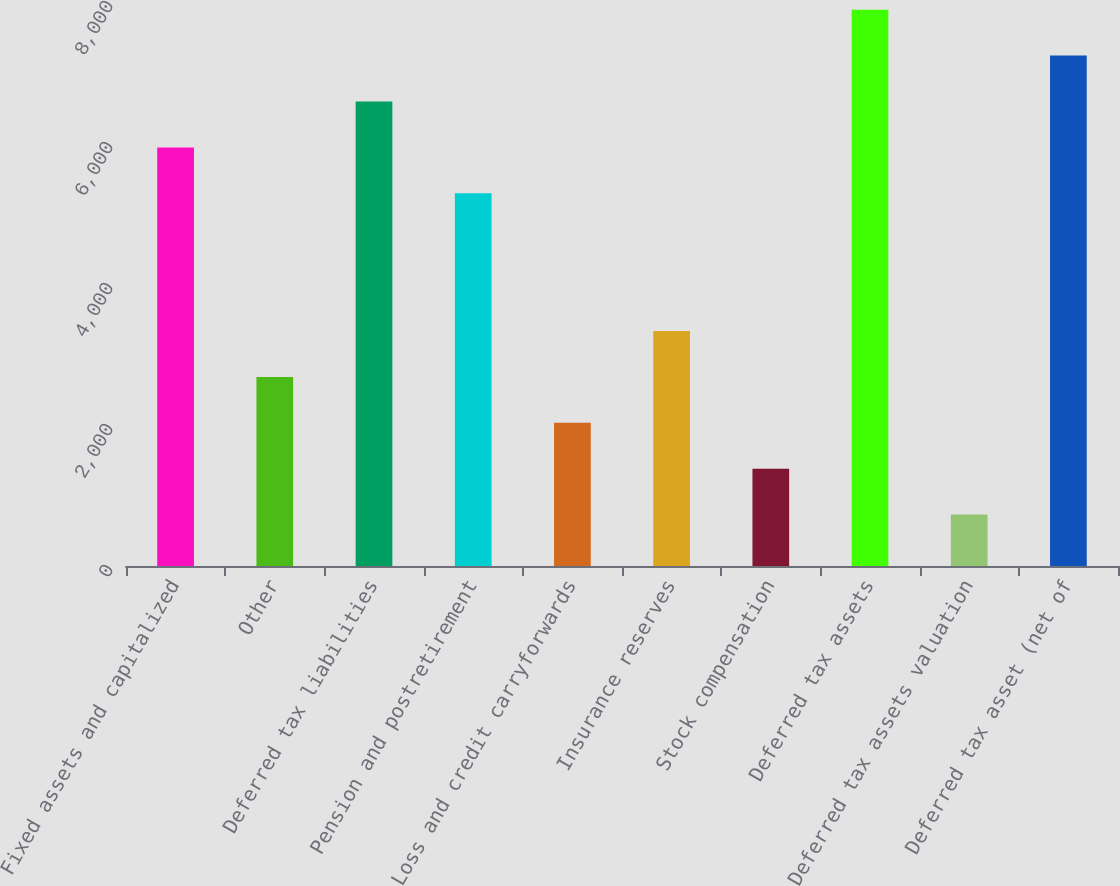Convert chart. <chart><loc_0><loc_0><loc_500><loc_500><bar_chart><fcel>Fixed assets and capitalized<fcel>Other<fcel>Deferred tax liabilities<fcel>Pension and postretirement<fcel>Loss and credit carryforwards<fcel>Insurance reserves<fcel>Stock compensation<fcel>Deferred tax assets<fcel>Deferred tax assets valuation<fcel>Deferred tax asset (net of<nl><fcel>5937.9<fcel>2682.4<fcel>6589<fcel>5286.8<fcel>2031.3<fcel>3333.5<fcel>1380.2<fcel>7891.2<fcel>729.1<fcel>7240.1<nl></chart> 